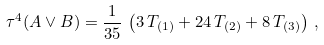Convert formula to latex. <formula><loc_0><loc_0><loc_500><loc_500>\tau ^ { 4 } ( A \vee B ) & = \frac { 1 } { 3 5 } \, \left ( 3 \, T _ { ( 1 ) } + 2 4 \, T _ { ( 2 ) } + 8 \, T _ { ( 3 ) } \right ) \, ,</formula> 